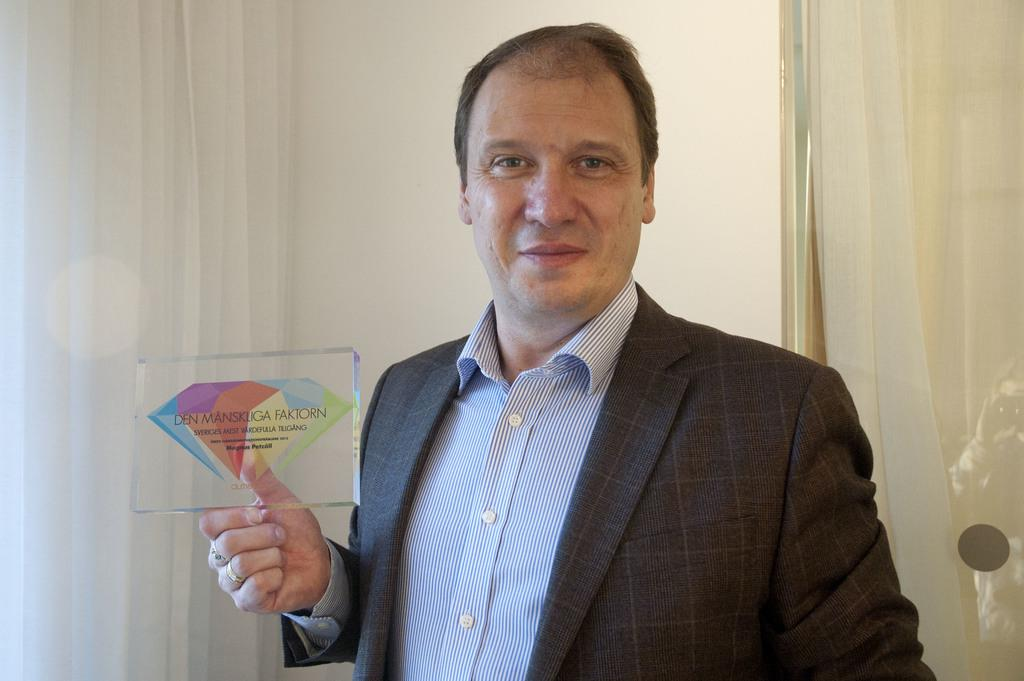What is the person holding in the image? The person is holding a glass cube in the image. What can be observed about the design on the glass cube? The glass cube has a colorful design on it. Are there any words or letters on the glass cube? Yes, the glass cube has text on it. What can be seen in the background of the image? There is a wall and a curtain in the background of the image. What type of cow can be seen grazing in the background of the image? There is no cow present in the image; the background features a wall and a curtain. Who is the porter assisting in the image? There is no porter present in the image; the person is holding a glass cube. 